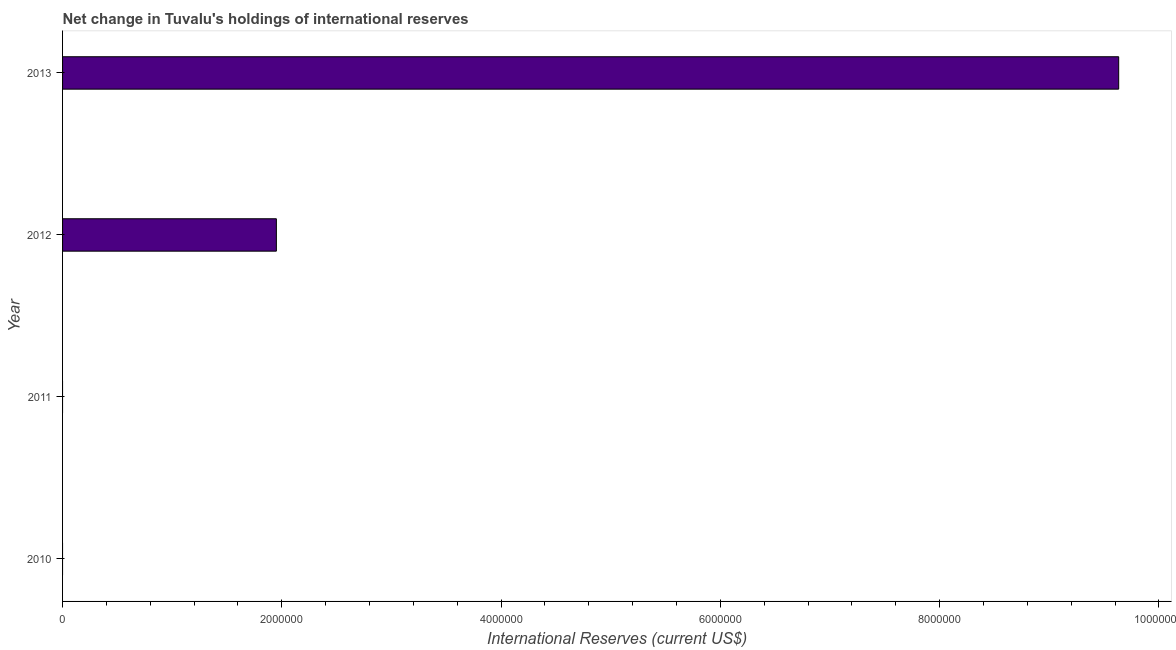What is the title of the graph?
Offer a very short reply. Net change in Tuvalu's holdings of international reserves. What is the label or title of the X-axis?
Keep it short and to the point. International Reserves (current US$). What is the label or title of the Y-axis?
Give a very brief answer. Year. What is the reserves and related items in 2012?
Provide a succinct answer. 1.95e+06. Across all years, what is the maximum reserves and related items?
Offer a terse response. 9.63e+06. What is the sum of the reserves and related items?
Provide a short and direct response. 1.16e+07. What is the average reserves and related items per year?
Your response must be concise. 2.90e+06. What is the median reserves and related items?
Give a very brief answer. 9.75e+05. In how many years, is the reserves and related items greater than 800000 US$?
Offer a terse response. 2. What is the ratio of the reserves and related items in 2012 to that in 2013?
Offer a terse response. 0.2. What is the difference between the highest and the lowest reserves and related items?
Give a very brief answer. 9.63e+06. In how many years, is the reserves and related items greater than the average reserves and related items taken over all years?
Offer a very short reply. 1. How many bars are there?
Ensure brevity in your answer.  2. What is the difference between two consecutive major ticks on the X-axis?
Keep it short and to the point. 2.00e+06. Are the values on the major ticks of X-axis written in scientific E-notation?
Your answer should be very brief. No. What is the International Reserves (current US$) in 2010?
Your answer should be compact. 0. What is the International Reserves (current US$) of 2011?
Provide a succinct answer. 0. What is the International Reserves (current US$) of 2012?
Your answer should be very brief. 1.95e+06. What is the International Reserves (current US$) of 2013?
Your response must be concise. 9.63e+06. What is the difference between the International Reserves (current US$) in 2012 and 2013?
Ensure brevity in your answer.  -7.68e+06. What is the ratio of the International Reserves (current US$) in 2012 to that in 2013?
Provide a succinct answer. 0.2. 